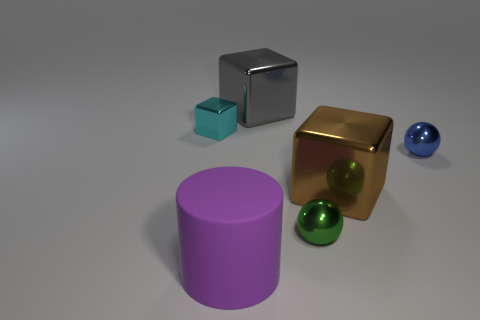Is there any other thing that is the same material as the purple cylinder?
Offer a very short reply. No. What color is the other big thing that is the same material as the large brown thing?
Offer a very short reply. Gray. There is a small ball behind the big shiny object right of the tiny green metal object; how many large blocks are on the left side of it?
Make the answer very short. 2. Is there any other thing that is the same shape as the purple object?
Ensure brevity in your answer.  No. What number of things are tiny objects on the right side of the tiny green thing or tiny yellow spheres?
Make the answer very short. 1. There is a sphere that is right of the small green thing; is its color the same as the big rubber cylinder?
Your answer should be compact. No. There is a tiny blue object to the right of the big metallic thing behind the blue object; what shape is it?
Your answer should be very brief. Sphere. Is the number of large rubber cylinders that are on the right side of the gray shiny thing less than the number of big cylinders that are behind the purple cylinder?
Provide a succinct answer. No. There is a brown object that is the same shape as the gray shiny thing; what is its size?
Offer a terse response. Large. What number of things are either small spheres that are in front of the tiny blue metallic thing or large things that are behind the big cylinder?
Your answer should be compact. 3. 